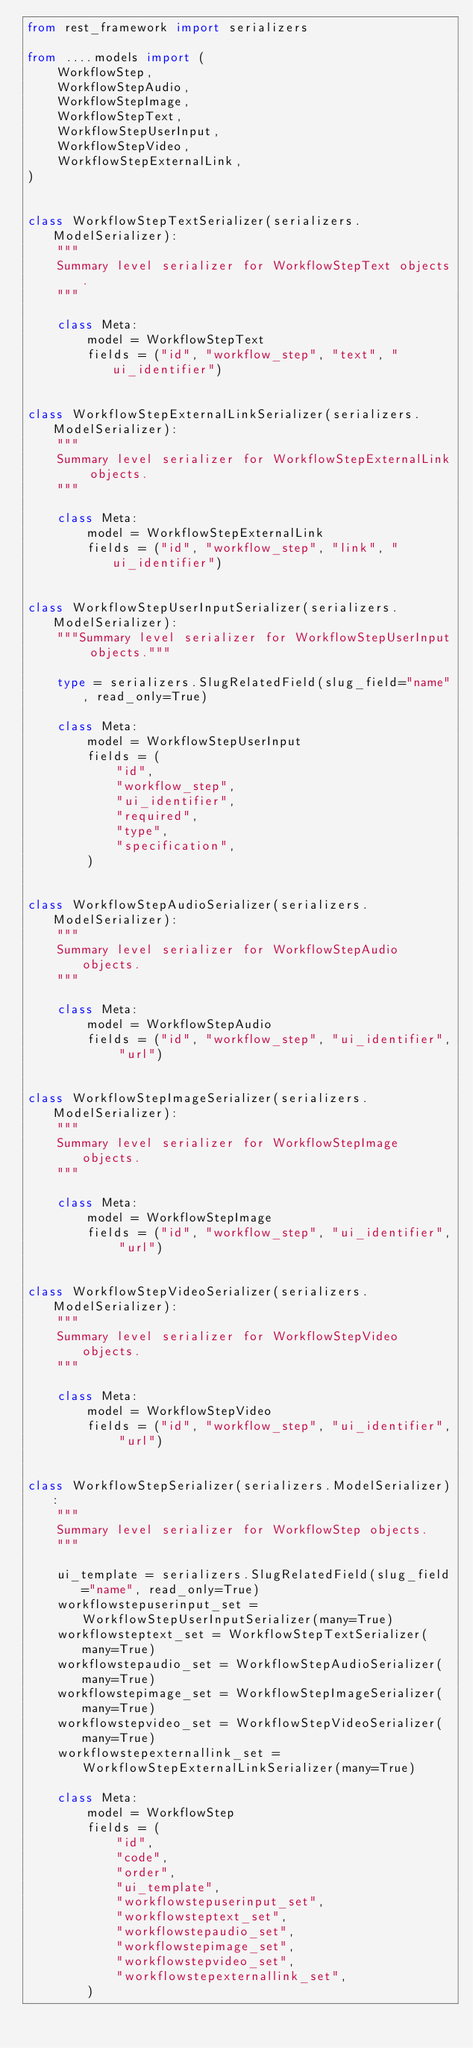<code> <loc_0><loc_0><loc_500><loc_500><_Python_>from rest_framework import serializers

from ....models import (
    WorkflowStep,
    WorkflowStepAudio,
    WorkflowStepImage,
    WorkflowStepText,
    WorkflowStepUserInput,
    WorkflowStepVideo,
    WorkflowStepExternalLink,
)


class WorkflowStepTextSerializer(serializers.ModelSerializer):
    """
    Summary level serializer for WorkflowStepText objects.
    """

    class Meta:
        model = WorkflowStepText
        fields = ("id", "workflow_step", "text", "ui_identifier")


class WorkflowStepExternalLinkSerializer(serializers.ModelSerializer):
    """
    Summary level serializer for WorkflowStepExternalLink objects.
    """

    class Meta:
        model = WorkflowStepExternalLink
        fields = ("id", "workflow_step", "link", "ui_identifier")


class WorkflowStepUserInputSerializer(serializers.ModelSerializer):
    """Summary level serializer for WorkflowStepUserInput objects."""

    type = serializers.SlugRelatedField(slug_field="name", read_only=True)

    class Meta:
        model = WorkflowStepUserInput
        fields = (
            "id",
            "workflow_step",
            "ui_identifier",
            "required",
            "type",
            "specification",
        )


class WorkflowStepAudioSerializer(serializers.ModelSerializer):
    """
    Summary level serializer for WorkflowStepAudio  objects.
    """

    class Meta:
        model = WorkflowStepAudio
        fields = ("id", "workflow_step", "ui_identifier", "url")


class WorkflowStepImageSerializer(serializers.ModelSerializer):
    """
    Summary level serializer for WorkflowStepImage objects.
    """

    class Meta:
        model = WorkflowStepImage
        fields = ("id", "workflow_step", "ui_identifier", "url")


class WorkflowStepVideoSerializer(serializers.ModelSerializer):
    """
    Summary level serializer for WorkflowStepVideo objects.
    """

    class Meta:
        model = WorkflowStepVideo
        fields = ("id", "workflow_step", "ui_identifier", "url")


class WorkflowStepSerializer(serializers.ModelSerializer):
    """
    Summary level serializer for WorkflowStep objects.
    """

    ui_template = serializers.SlugRelatedField(slug_field="name", read_only=True)
    workflowstepuserinput_set = WorkflowStepUserInputSerializer(many=True)
    workflowsteptext_set = WorkflowStepTextSerializer(many=True)
    workflowstepaudio_set = WorkflowStepAudioSerializer(many=True)
    workflowstepimage_set = WorkflowStepImageSerializer(many=True)
    workflowstepvideo_set = WorkflowStepVideoSerializer(many=True)
    workflowstepexternallink_set = WorkflowStepExternalLinkSerializer(many=True)

    class Meta:
        model = WorkflowStep
        fields = (
            "id",
            "code",
            "order",
            "ui_template",
            "workflowstepuserinput_set",
            "workflowsteptext_set",
            "workflowstepaudio_set",
            "workflowstepimage_set",
            "workflowstepvideo_set",
            "workflowstepexternallink_set",
        )
</code> 